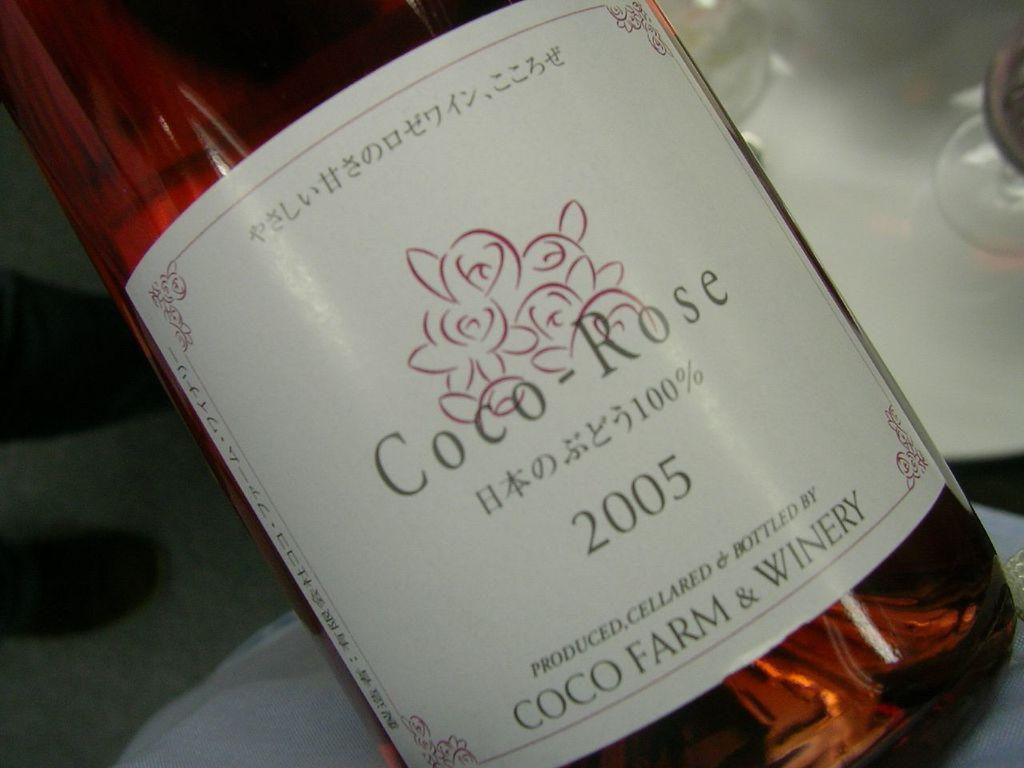<image>
Summarize the visual content of the image. The alcohol is labeled Rose in the image. 